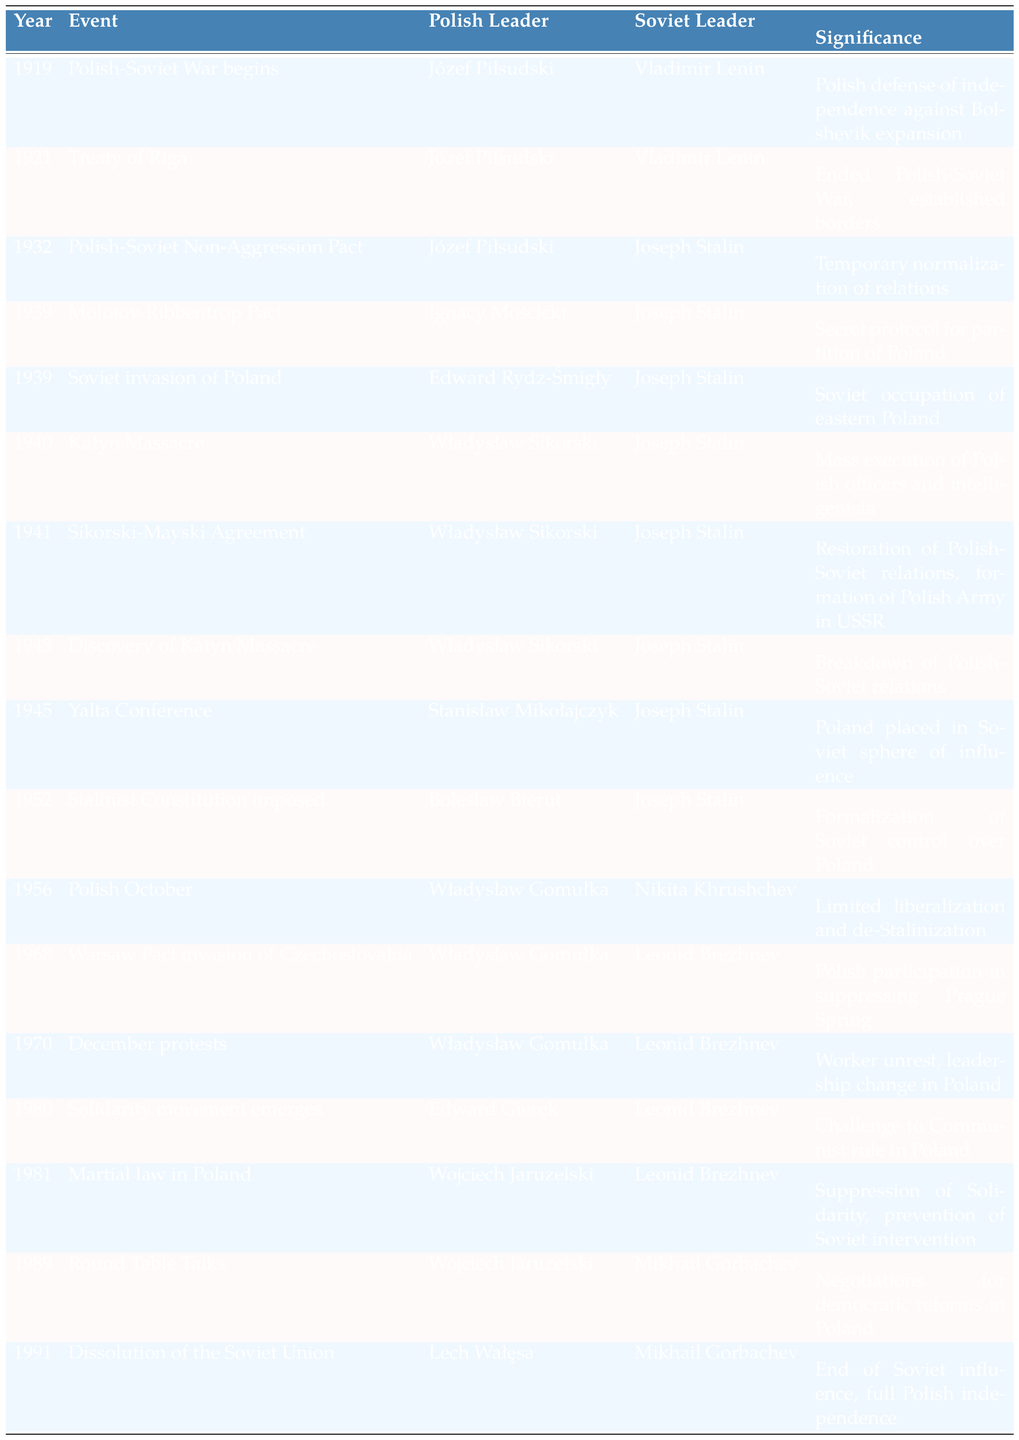What year did the Polish-Soviet War begin? The table indicates that the Polish-Soviet War began in 1919, which is clearly stated in the corresponding row.
Answer: 1919 Who was the Polish leader during the signing of the Treaty of Riga? According to the table, Józef Piłsudski was the Polish leader when the Treaty of Riga was signed in 1921.
Answer: Józef Piłsudski What event occurred in 1943 regarding the Katyn Massacre? The table shows that in 1943, the Discovery of the Katyn Massacre took place, indicating a significant event in Polish-Soviet relations.
Answer: Discovery of Katyn Massacre How many times did Józef Piłsudski lead Poland in relations with Soviet leaders? From the table, Józef Piłsudski led Poland during three events: the Polish-Soviet War, the Treaty of Riga, and the Polish-Soviet Non-Aggression Pact.
Answer: 3 What was the significance of the Molotov-Ribbentrop Pact according to the table? The table states that the significance of the Molotov-Ribbentrop Pact in 1939 was the secret protocol for the partition of Poland.
Answer: Secret protocol for partition of Poland During which event did Władysław Sikorski serve as a leader? Władysław Sikorski is listed as the Polish leader during the Katyn Massacre and the Sikorski-Mayski Agreement.
Answer: Katyn Massacre and Sikorski-Mayski Agreement In which year was martial law declared in Poland? The table specifies that martial law in Poland was declared in 1981.
Answer: 1981 What were the significant events occurring in 1939 in Polish-Soviet relations? According to the table, two significant events occurred in 1939: the Molotov-Ribbentrop Pact and the Soviet invasion of Poland.
Answer: Molotov-Ribbentrop Pact and Soviet invasion of Poland Which Polish leader was in power during the 1980 Solidarity movement? The leader during the Solidarity movement in 1980 was Edward Gierek, as stated in the table.
Answer: Edward Gierek How did the Yalta Conference impact Poland, based on the table? The table reflects that the Yalta Conference in 1945 placed Poland in the Soviet sphere of influence, marking a critical moment in its history.
Answer: Poland placed in Soviet sphere of influence Count the number of events that involved Joseph Stalin as the Soviet leader. By examining the table, Joseph Stalin appears as the Soviet leader in six different events, including the Polish-Soviet War and the Katyn Massacre.
Answer: 6 Was the Polish-Soviet Non-Aggression Pact a permanent agreement? The significance of the Polish-Soviet Non-Aggression Pact, according to the table, indicates it was a temporary normalization of relations, thus it was not permanent.
Answer: No Identify the leader who negotiated the Round Table Talks in 1989. The table lists Wojciech Jaruzelski as the Polish leader involved in the Round Table Talks of 1989.
Answer: Wojciech Jaruzelski What was the event that directly led to the breakdown of relations in 1943? The table indicates that the Discovery of the Katyn Massacre in 1943 led to the breakdown of Polish-Soviet relations.
Answer: Discovery of Katyn Massacre Which leader was associated with the declaration of the Stalinist Constitution in 1952? The table states that Bolesław Bierut was the Polish leader associated with the imposition of the Stalinist Constitution in 1952.
Answer: Bolesław Bierut What can be inferred about the continuity of Polish leaders from 1919 to 1991? The table shows a transition of Polish leadership from Józef Piłsudski in 1919 to Lech Wałęsa in 1991, indicating both continuity and change over several decades.
Answer: Transition from Piłsudski to Wałęsa 